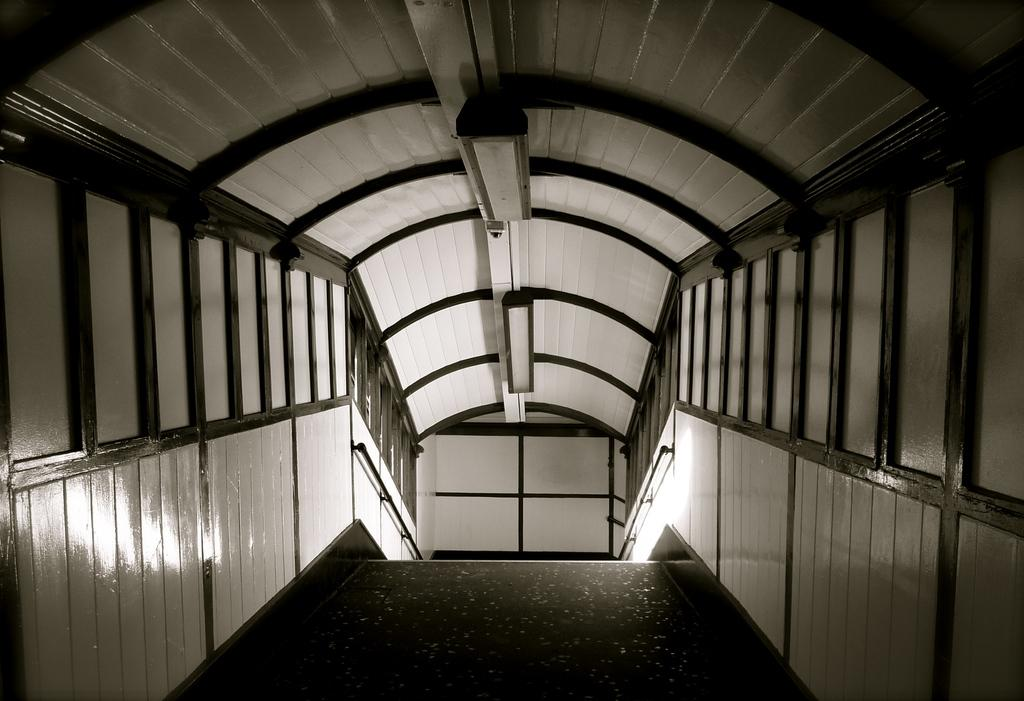What type of material is used for the walls in the image? The walls in the image are made of wood. What structure is present above the walls in the image? There is a roof in the image. What can be seen providing illumination in the image? There are lights in the image. What is visible at the bottom of the image? The ground is visible towards the bottom of the image. How many cats are playing with plastic toys in the image? There are no cats or plastic toys present in the image. 